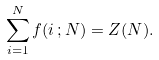Convert formula to latex. <formula><loc_0><loc_0><loc_500><loc_500>\sum _ { i = 1 } ^ { N } f ( i \, ; N ) = Z ( N ) .</formula> 